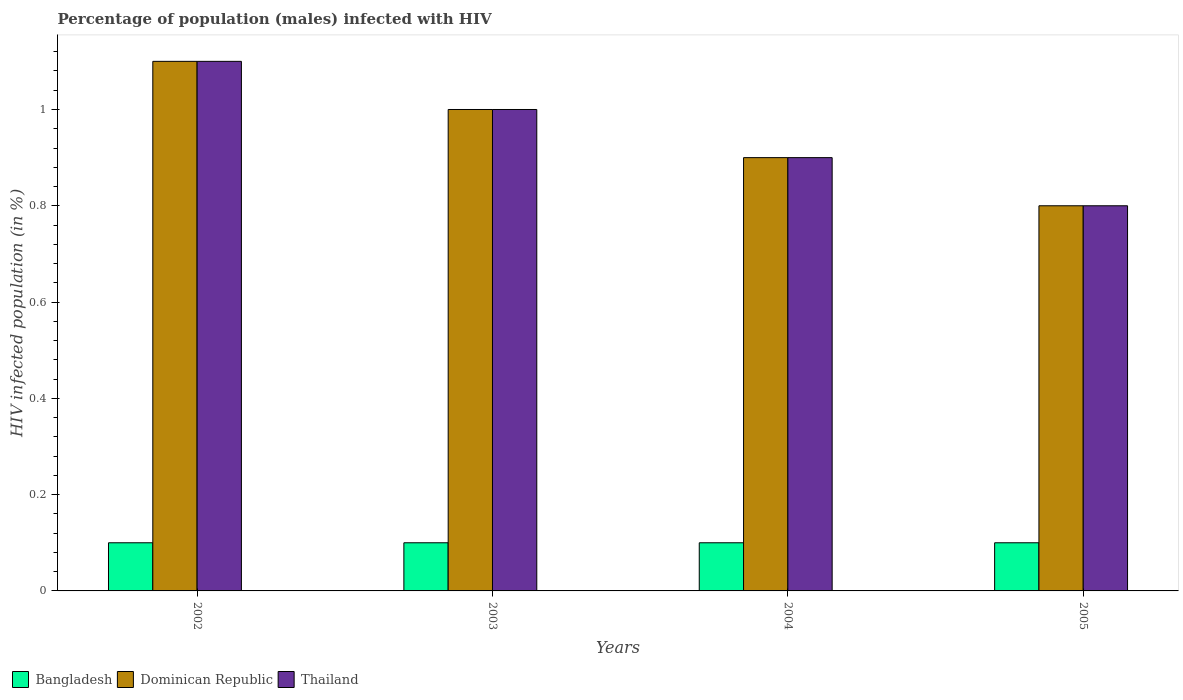How many different coloured bars are there?
Provide a succinct answer. 3. Are the number of bars on each tick of the X-axis equal?
Offer a very short reply. Yes. How many bars are there on the 1st tick from the right?
Your answer should be very brief. 3. What is the label of the 2nd group of bars from the left?
Make the answer very short. 2003. Across all years, what is the minimum percentage of HIV infected male population in Bangladesh?
Your response must be concise. 0.1. In which year was the percentage of HIV infected male population in Thailand maximum?
Ensure brevity in your answer.  2002. What is the total percentage of HIV infected male population in Thailand in the graph?
Offer a very short reply. 3.8. What is the difference between the percentage of HIV infected male population in Thailand in 2004 and that in 2005?
Your answer should be very brief. 0.1. What is the difference between the percentage of HIV infected male population in Dominican Republic in 2003 and the percentage of HIV infected male population in Thailand in 2004?
Keep it short and to the point. 0.1. What is the ratio of the percentage of HIV infected male population in Dominican Republic in 2002 to that in 2005?
Keep it short and to the point. 1.38. Is the percentage of HIV infected male population in Thailand in 2003 less than that in 2005?
Your response must be concise. No. What is the difference between the highest and the second highest percentage of HIV infected male population in Dominican Republic?
Provide a short and direct response. 0.1. Is the sum of the percentage of HIV infected male population in Thailand in 2004 and 2005 greater than the maximum percentage of HIV infected male population in Bangladesh across all years?
Your response must be concise. Yes. What does the 2nd bar from the right in 2002 represents?
Keep it short and to the point. Dominican Republic. How many years are there in the graph?
Make the answer very short. 4. What is the difference between two consecutive major ticks on the Y-axis?
Make the answer very short. 0.2. Are the values on the major ticks of Y-axis written in scientific E-notation?
Provide a short and direct response. No. Does the graph contain grids?
Offer a terse response. No. How many legend labels are there?
Offer a very short reply. 3. What is the title of the graph?
Keep it short and to the point. Percentage of population (males) infected with HIV. What is the label or title of the X-axis?
Make the answer very short. Years. What is the label or title of the Y-axis?
Offer a very short reply. HIV infected population (in %). What is the HIV infected population (in %) of Bangladesh in 2002?
Your response must be concise. 0.1. What is the HIV infected population (in %) of Dominican Republic in 2003?
Your response must be concise. 1. What is the HIV infected population (in %) in Dominican Republic in 2004?
Give a very brief answer. 0.9. What is the HIV infected population (in %) of Thailand in 2004?
Your response must be concise. 0.9. What is the HIV infected population (in %) in Dominican Republic in 2005?
Give a very brief answer. 0.8. Across all years, what is the maximum HIV infected population (in %) of Thailand?
Keep it short and to the point. 1.1. Across all years, what is the minimum HIV infected population (in %) in Bangladesh?
Your answer should be very brief. 0.1. Across all years, what is the minimum HIV infected population (in %) of Thailand?
Provide a succinct answer. 0.8. What is the total HIV infected population (in %) of Dominican Republic in the graph?
Your response must be concise. 3.8. What is the difference between the HIV infected population (in %) in Bangladesh in 2002 and that in 2004?
Provide a short and direct response. 0. What is the difference between the HIV infected population (in %) of Dominican Republic in 2002 and that in 2004?
Keep it short and to the point. 0.2. What is the difference between the HIV infected population (in %) in Thailand in 2002 and that in 2004?
Ensure brevity in your answer.  0.2. What is the difference between the HIV infected population (in %) of Bangladesh in 2002 and that in 2005?
Make the answer very short. 0. What is the difference between the HIV infected population (in %) in Thailand in 2002 and that in 2005?
Offer a very short reply. 0.3. What is the difference between the HIV infected population (in %) of Bangladesh in 2003 and that in 2005?
Offer a terse response. 0. What is the difference between the HIV infected population (in %) in Dominican Republic in 2003 and that in 2005?
Your answer should be very brief. 0.2. What is the difference between the HIV infected population (in %) of Bangladesh in 2004 and that in 2005?
Provide a short and direct response. 0. What is the difference between the HIV infected population (in %) of Dominican Republic in 2004 and that in 2005?
Your answer should be very brief. 0.1. What is the difference between the HIV infected population (in %) in Thailand in 2004 and that in 2005?
Make the answer very short. 0.1. What is the difference between the HIV infected population (in %) in Dominican Republic in 2002 and the HIV infected population (in %) in Thailand in 2003?
Provide a succinct answer. 0.1. What is the difference between the HIV infected population (in %) in Bangladesh in 2002 and the HIV infected population (in %) in Dominican Republic in 2004?
Ensure brevity in your answer.  -0.8. What is the difference between the HIV infected population (in %) in Bangladesh in 2002 and the HIV infected population (in %) in Thailand in 2005?
Offer a very short reply. -0.7. What is the difference between the HIV infected population (in %) of Dominican Republic in 2002 and the HIV infected population (in %) of Thailand in 2005?
Ensure brevity in your answer.  0.3. What is the difference between the HIV infected population (in %) of Bangladesh in 2003 and the HIV infected population (in %) of Thailand in 2004?
Offer a very short reply. -0.8. What is the difference between the HIV infected population (in %) in Bangladesh in 2003 and the HIV infected population (in %) in Dominican Republic in 2005?
Keep it short and to the point. -0.7. What is the difference between the HIV infected population (in %) in Bangladesh in 2003 and the HIV infected population (in %) in Thailand in 2005?
Give a very brief answer. -0.7. What is the difference between the HIV infected population (in %) in Bangladesh in 2004 and the HIV infected population (in %) in Thailand in 2005?
Provide a succinct answer. -0.7. What is the difference between the HIV infected population (in %) of Dominican Republic in 2004 and the HIV infected population (in %) of Thailand in 2005?
Your answer should be very brief. 0.1. What is the average HIV infected population (in %) of Dominican Republic per year?
Keep it short and to the point. 0.95. In the year 2002, what is the difference between the HIV infected population (in %) in Bangladesh and HIV infected population (in %) in Dominican Republic?
Provide a succinct answer. -1. In the year 2002, what is the difference between the HIV infected population (in %) in Dominican Republic and HIV infected population (in %) in Thailand?
Provide a succinct answer. 0. In the year 2004, what is the difference between the HIV infected population (in %) of Bangladesh and HIV infected population (in %) of Thailand?
Ensure brevity in your answer.  -0.8. In the year 2004, what is the difference between the HIV infected population (in %) of Dominican Republic and HIV infected population (in %) of Thailand?
Provide a short and direct response. 0. In the year 2005, what is the difference between the HIV infected population (in %) of Bangladesh and HIV infected population (in %) of Thailand?
Your answer should be compact. -0.7. What is the ratio of the HIV infected population (in %) in Thailand in 2002 to that in 2003?
Make the answer very short. 1.1. What is the ratio of the HIV infected population (in %) of Dominican Republic in 2002 to that in 2004?
Your answer should be compact. 1.22. What is the ratio of the HIV infected population (in %) in Thailand in 2002 to that in 2004?
Your answer should be very brief. 1.22. What is the ratio of the HIV infected population (in %) of Dominican Republic in 2002 to that in 2005?
Your response must be concise. 1.38. What is the ratio of the HIV infected population (in %) in Thailand in 2002 to that in 2005?
Your response must be concise. 1.38. What is the ratio of the HIV infected population (in %) of Dominican Republic in 2003 to that in 2004?
Your response must be concise. 1.11. What is the ratio of the HIV infected population (in %) of Bangladesh in 2003 to that in 2005?
Provide a succinct answer. 1. What is the ratio of the HIV infected population (in %) in Dominican Republic in 2003 to that in 2005?
Give a very brief answer. 1.25. What is the ratio of the HIV infected population (in %) in Thailand in 2003 to that in 2005?
Your answer should be compact. 1.25. What is the ratio of the HIV infected population (in %) of Bangladesh in 2004 to that in 2005?
Ensure brevity in your answer.  1. What is the ratio of the HIV infected population (in %) in Thailand in 2004 to that in 2005?
Provide a short and direct response. 1.12. What is the difference between the highest and the second highest HIV infected population (in %) of Bangladesh?
Give a very brief answer. 0. What is the difference between the highest and the second highest HIV infected population (in %) of Thailand?
Provide a succinct answer. 0.1. 